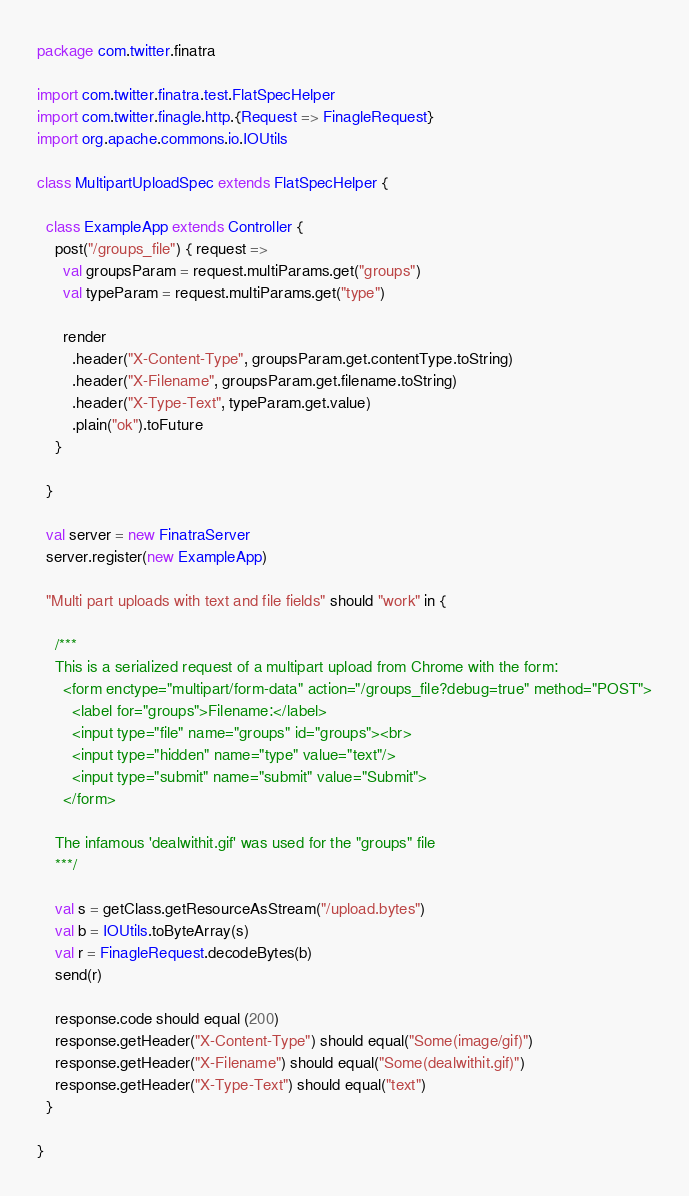Convert code to text. <code><loc_0><loc_0><loc_500><loc_500><_Scala_>package com.twitter.finatra

import com.twitter.finatra.test.FlatSpecHelper
import com.twitter.finagle.http.{Request => FinagleRequest}
import org.apache.commons.io.IOUtils

class MultipartUploadSpec extends FlatSpecHelper {

  class ExampleApp extends Controller {
    post("/groups_file") { request =>
      val groupsParam = request.multiParams.get("groups")
      val typeParam = request.multiParams.get("type")

      render
        .header("X-Content-Type", groupsParam.get.contentType.toString)
        .header("X-Filename", groupsParam.get.filename.toString)
        .header("X-Type-Text", typeParam.get.value)
        .plain("ok").toFuture
    }

  }

  val server = new FinatraServer
  server.register(new ExampleApp)

  "Multi part uploads with text and file fields" should "work" in {

    /***
    This is a serialized request of a multipart upload from Chrome with the form:
      <form enctype="multipart/form-data" action="/groups_file?debug=true" method="POST">
        <label for="groups">Filename:</label>
        <input type="file" name="groups" id="groups"><br>
        <input type="hidden" name="type" value="text"/>
        <input type="submit" name="submit" value="Submit">
      </form>

    The infamous 'dealwithit.gif' was used for the "groups" file
    ***/

    val s = getClass.getResourceAsStream("/upload.bytes")
    val b = IOUtils.toByteArray(s)
    val r = FinagleRequest.decodeBytes(b)
    send(r)

    response.code should equal (200)
    response.getHeader("X-Content-Type") should equal("Some(image/gif)")
    response.getHeader("X-Filename") should equal("Some(dealwithit.gif)")
    response.getHeader("X-Type-Text") should equal("text")
  }

}
</code> 